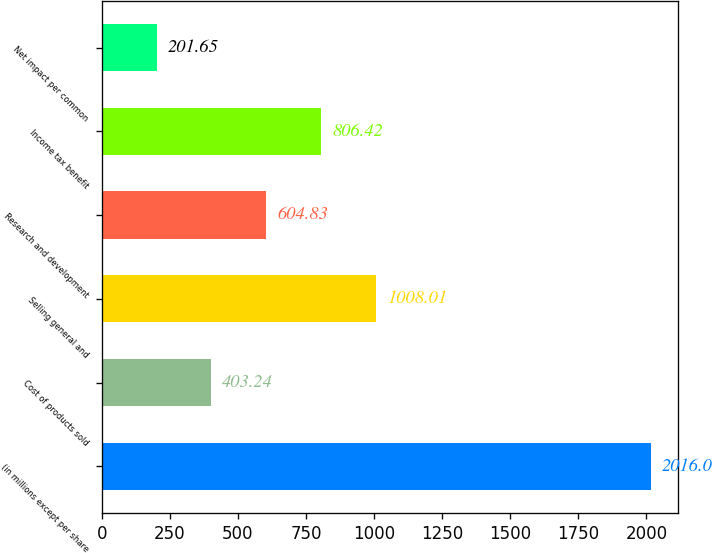<chart> <loc_0><loc_0><loc_500><loc_500><bar_chart><fcel>(in millions except per share<fcel>Cost of products sold<fcel>Selling general and<fcel>Research and development<fcel>Income tax benefit<fcel>Net impact per common<nl><fcel>2016<fcel>403.24<fcel>1008.01<fcel>604.83<fcel>806.42<fcel>201.65<nl></chart> 